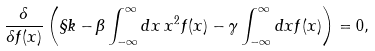Convert formula to latex. <formula><loc_0><loc_0><loc_500><loc_500>\frac { \delta } { \delta f ( x ) } \left ( \S k - \beta \int _ { - \infty } ^ { \infty } d x \, x ^ { 2 } f ( x ) - \gamma \int _ { - \infty } ^ { \infty } d x f ( x ) \right ) = 0 ,</formula> 